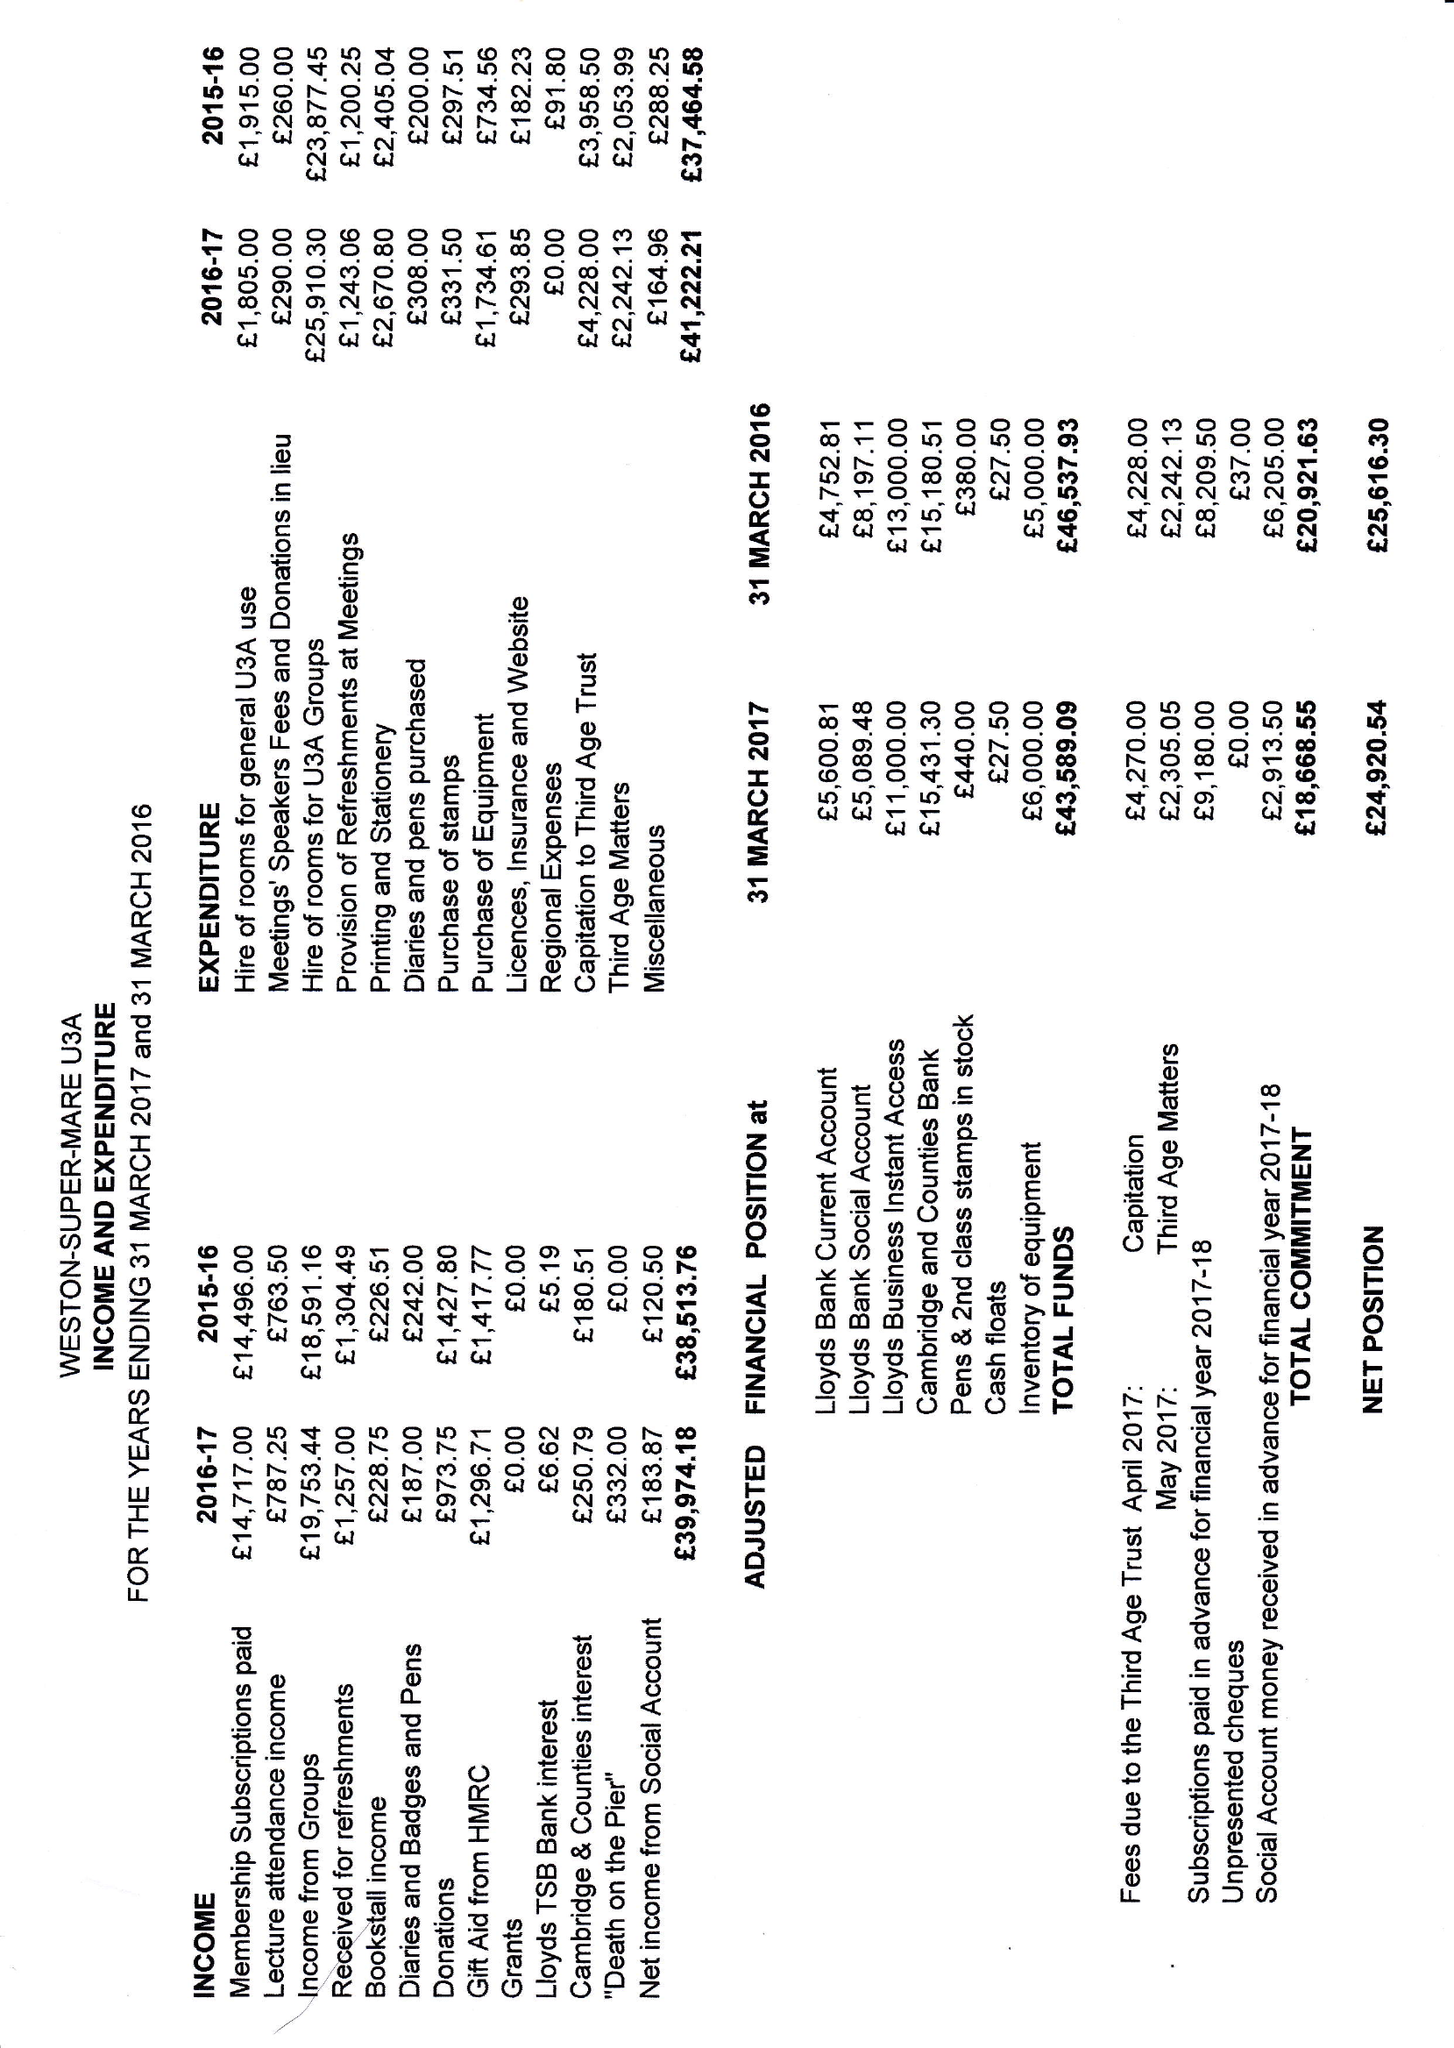What is the value for the report_date?
Answer the question using a single word or phrase. 2017-03-31 